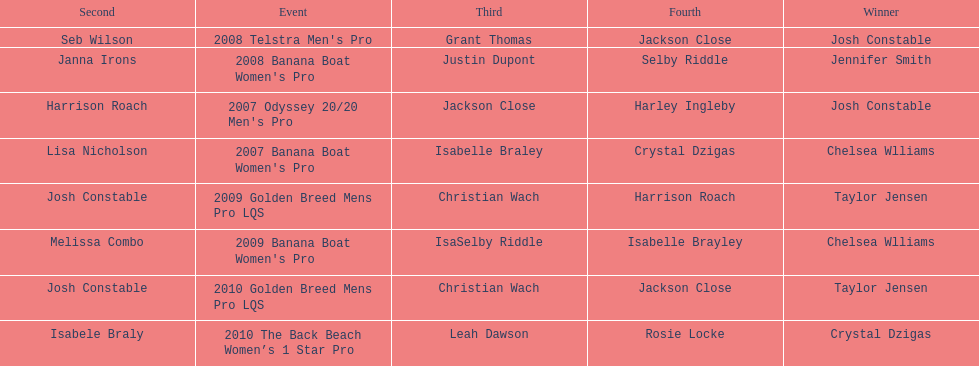At which event did taylor jensen first win? 2009 Golden Breed Mens Pro LQS. 